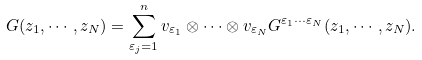Convert formula to latex. <formula><loc_0><loc_0><loc_500><loc_500>G ( z _ { 1 } , \cdots , z _ { N } ) = \sum _ { \varepsilon _ { j } = 1 } ^ { n } v _ { \varepsilon _ { 1 } } \otimes \cdots \otimes v _ { \varepsilon _ { N } } G ^ { \varepsilon _ { 1 } \cdots \varepsilon _ { N } } ( z _ { 1 } , \cdots , z _ { N } ) .</formula> 